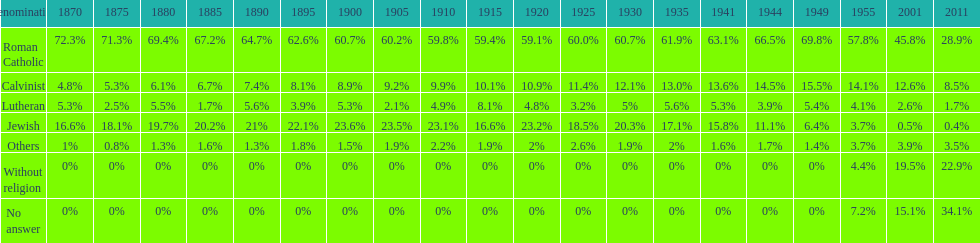What is the total percentage of people who identified as religious in 2011? 43%. 